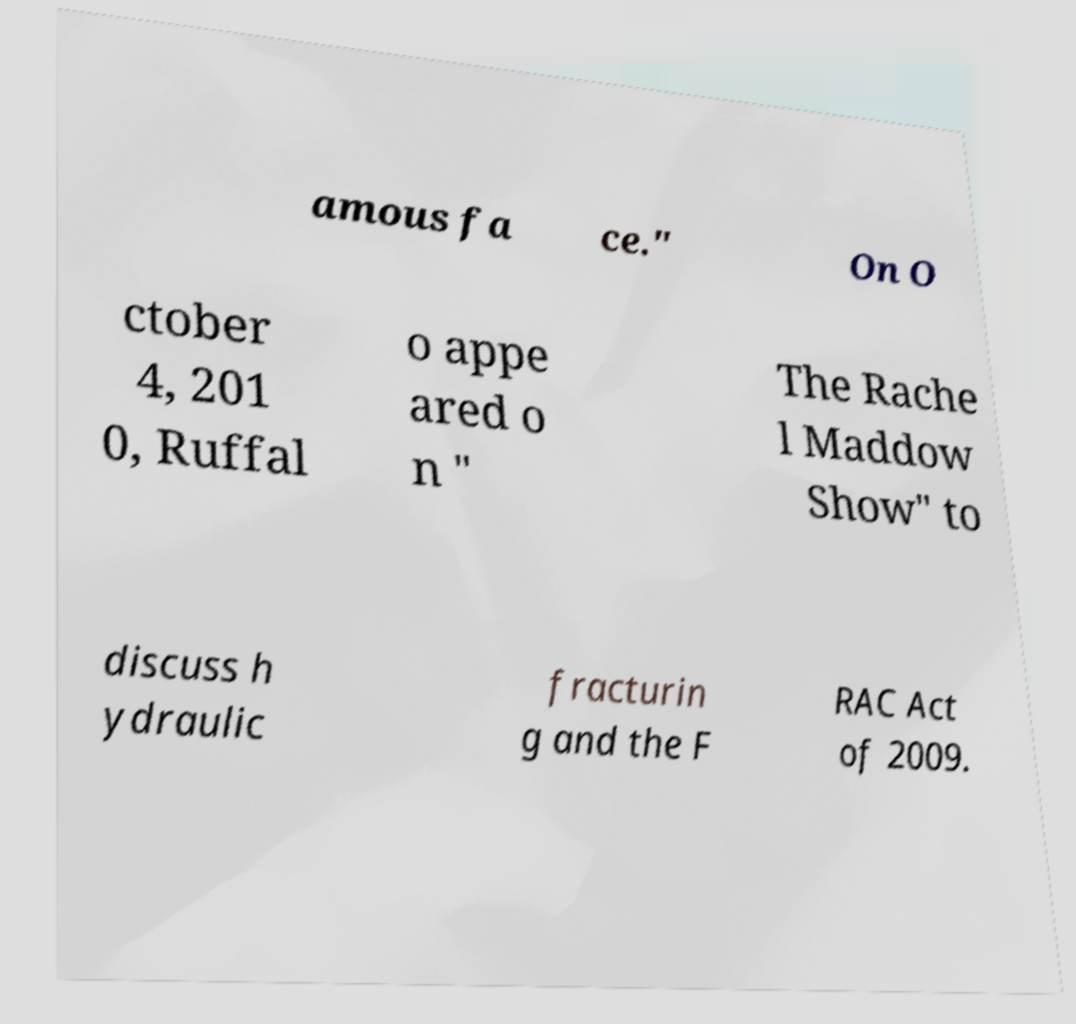Can you accurately transcribe the text from the provided image for me? amous fa ce." On O ctober 4, 201 0, Ruffal o appe ared o n " The Rache l Maddow Show" to discuss h ydraulic fracturin g and the F RAC Act of 2009. 